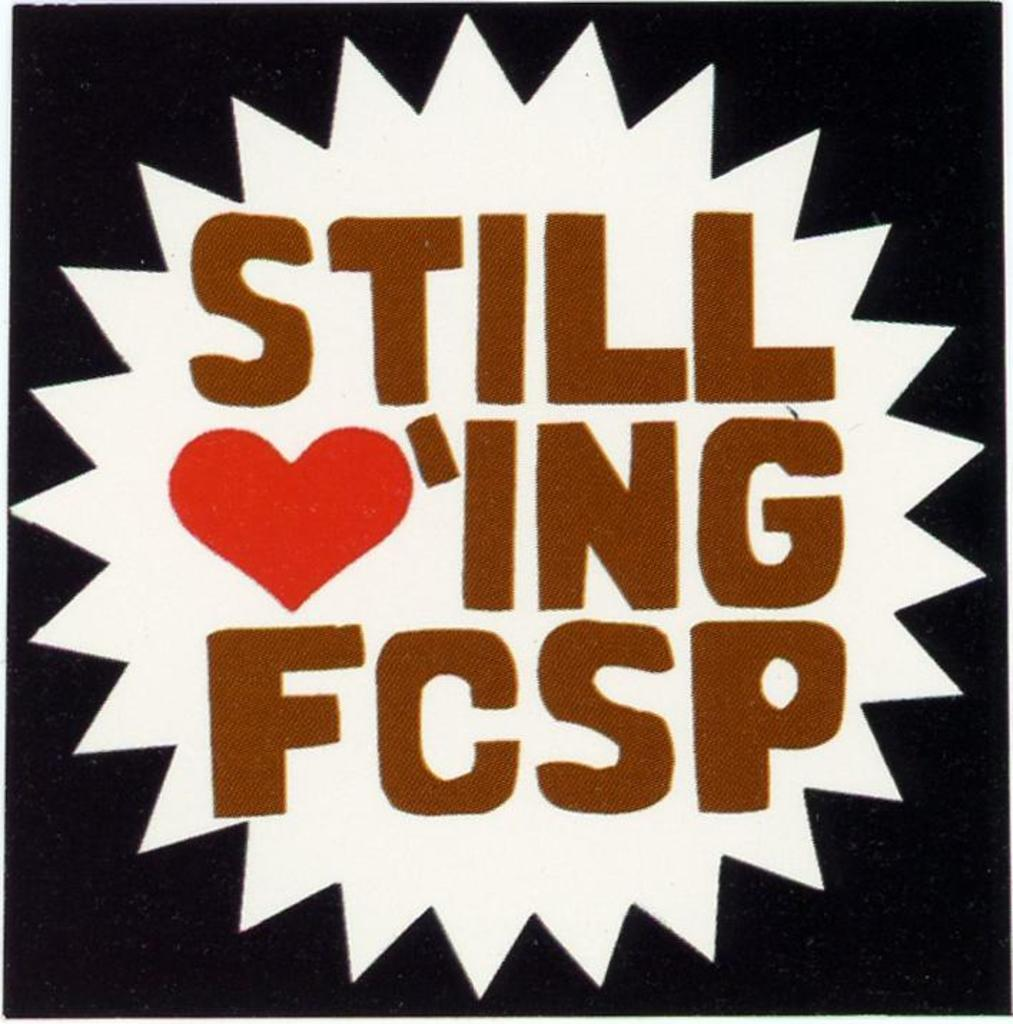<image>
Render a clear and concise summary of the photo. A black and white picture with the phrase Still Loving FCSP. 